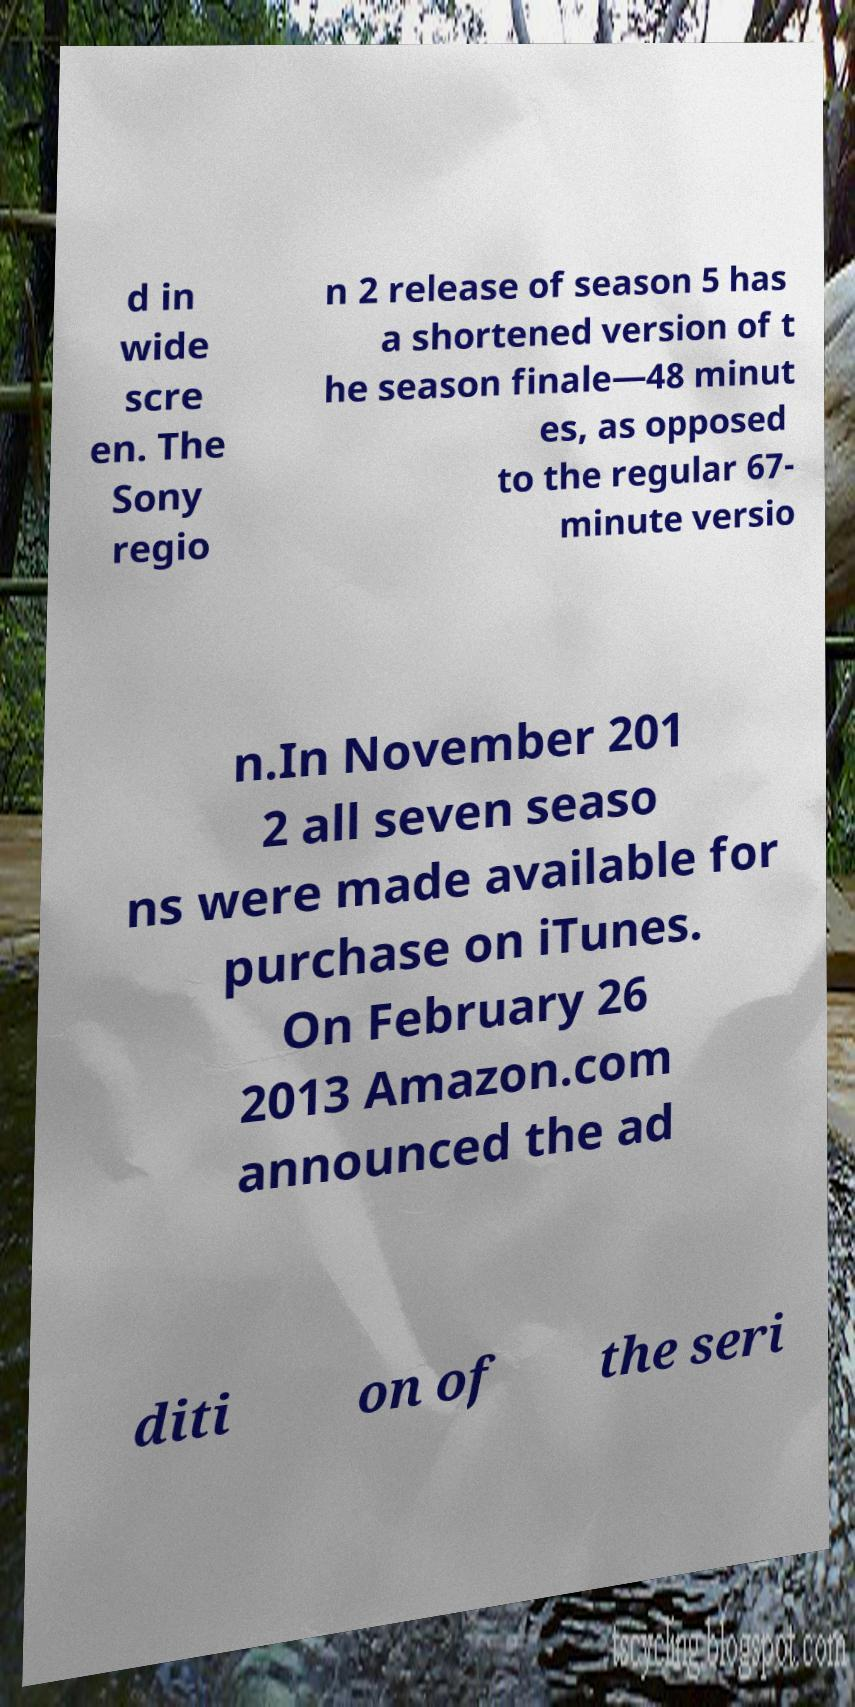For documentation purposes, I need the text within this image transcribed. Could you provide that? d in wide scre en. The Sony regio n 2 release of season 5 has a shortened version of t he season finale—48 minut es, as opposed to the regular 67- minute versio n.In November 201 2 all seven seaso ns were made available for purchase on iTunes. On February 26 2013 Amazon.com announced the ad diti on of the seri 